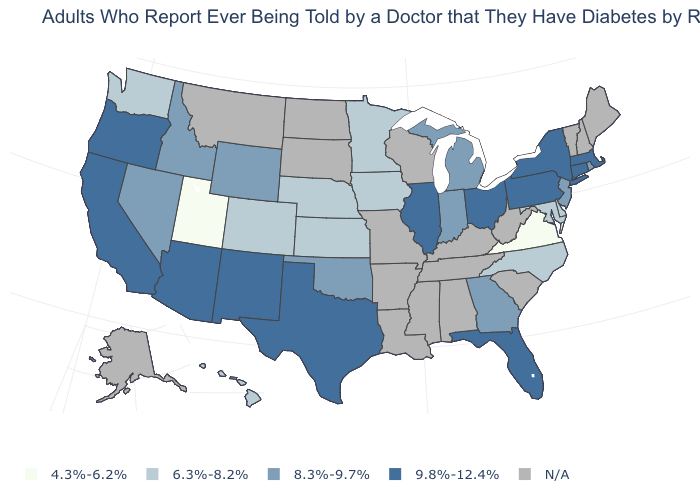What is the value of Idaho?
Write a very short answer. 8.3%-9.7%. Name the states that have a value in the range 4.3%-6.2%?
Quick response, please. Utah, Virginia. What is the value of New York?
Answer briefly. 9.8%-12.4%. Which states have the highest value in the USA?
Give a very brief answer. Arizona, California, Connecticut, Florida, Illinois, Massachusetts, New Mexico, New York, Ohio, Oregon, Pennsylvania, Texas. What is the lowest value in the West?
Write a very short answer. 4.3%-6.2%. What is the value of Michigan?
Quick response, please. 8.3%-9.7%. Among the states that border Arizona , does Utah have the highest value?
Give a very brief answer. No. What is the value of Oregon?
Be succinct. 9.8%-12.4%. Does Florida have the highest value in the South?
Concise answer only. Yes. What is the value of South Carolina?
Quick response, please. N/A. Name the states that have a value in the range 4.3%-6.2%?
Be succinct. Utah, Virginia. Name the states that have a value in the range 9.8%-12.4%?
Keep it brief. Arizona, California, Connecticut, Florida, Illinois, Massachusetts, New Mexico, New York, Ohio, Oregon, Pennsylvania, Texas. What is the value of Mississippi?
Write a very short answer. N/A. 